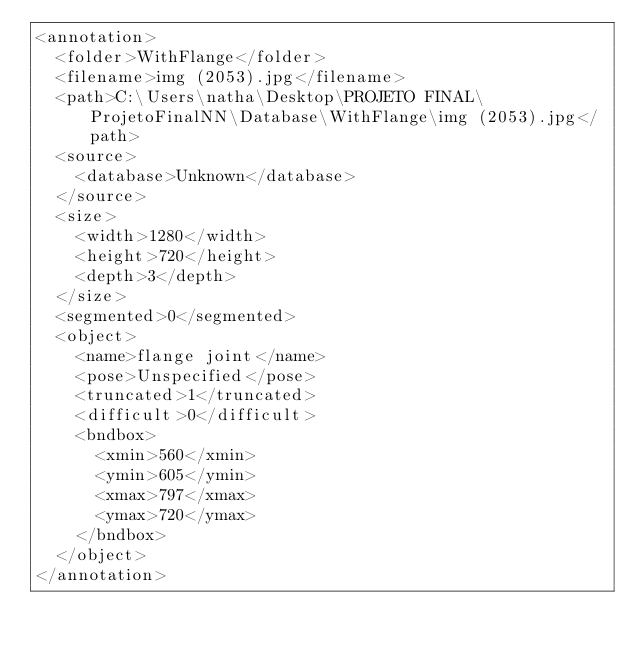<code> <loc_0><loc_0><loc_500><loc_500><_XML_><annotation>
	<folder>WithFlange</folder>
	<filename>img (2053).jpg</filename>
	<path>C:\Users\natha\Desktop\PROJETO FINAL\ProjetoFinalNN\Database\WithFlange\img (2053).jpg</path>
	<source>
		<database>Unknown</database>
	</source>
	<size>
		<width>1280</width>
		<height>720</height>
		<depth>3</depth>
	</size>
	<segmented>0</segmented>
	<object>
		<name>flange joint</name>
		<pose>Unspecified</pose>
		<truncated>1</truncated>
		<difficult>0</difficult>
		<bndbox>
			<xmin>560</xmin>
			<ymin>605</ymin>
			<xmax>797</xmax>
			<ymax>720</ymax>
		</bndbox>
	</object>
</annotation>
</code> 